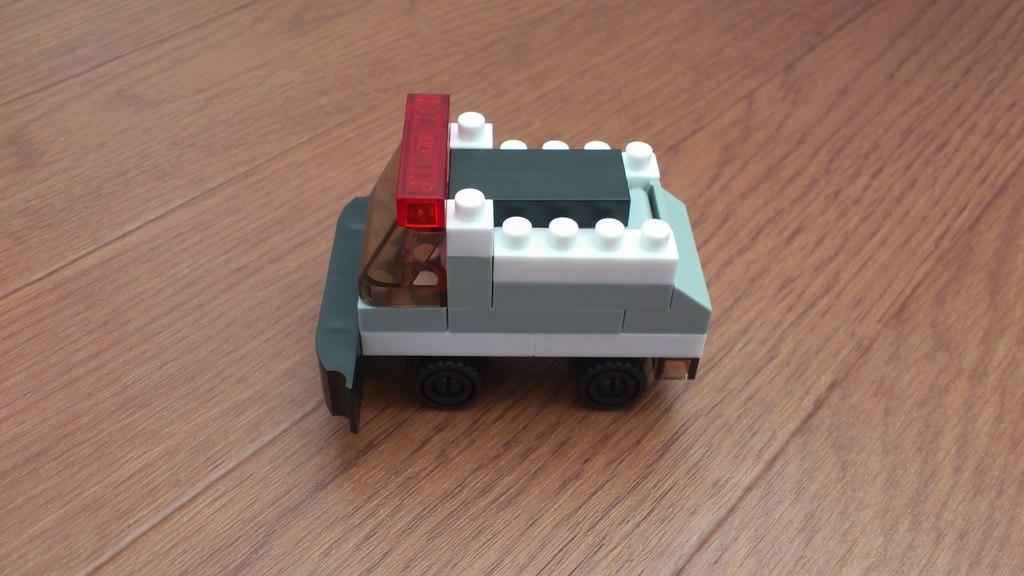Can you describe this image briefly? In the image in the center, we can see one table. On the table, there is a toy vehicle, which is in a different color. 